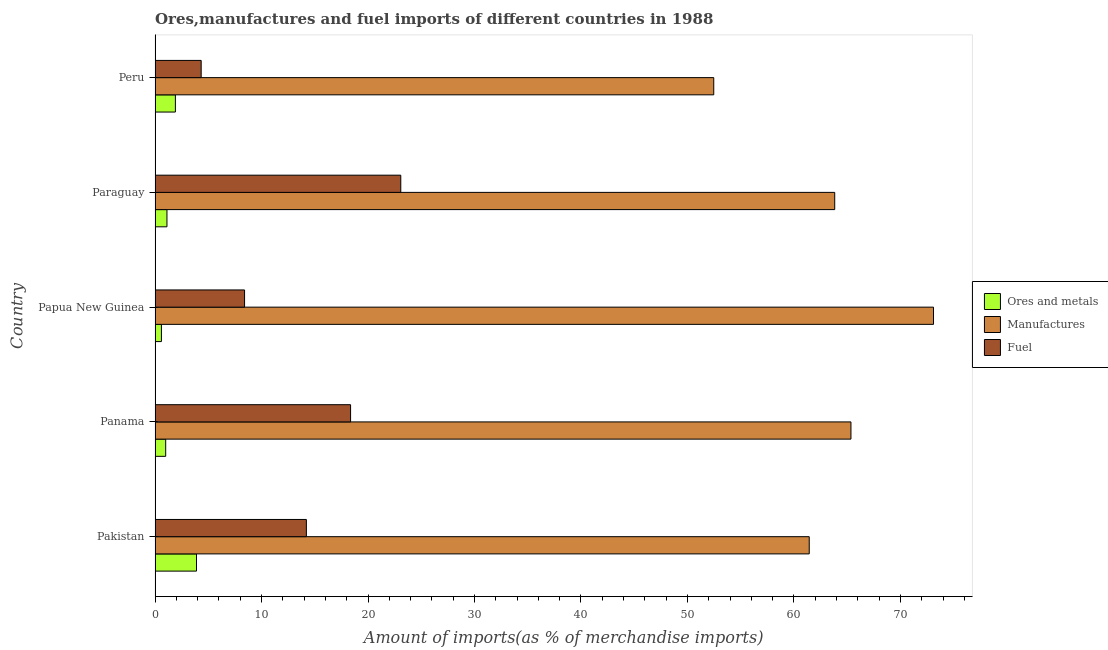How many groups of bars are there?
Offer a very short reply. 5. Are the number of bars per tick equal to the number of legend labels?
Ensure brevity in your answer.  Yes. Are the number of bars on each tick of the Y-axis equal?
Your response must be concise. Yes. In how many cases, is the number of bars for a given country not equal to the number of legend labels?
Offer a terse response. 0. What is the percentage of ores and metals imports in Pakistan?
Give a very brief answer. 3.89. Across all countries, what is the maximum percentage of manufactures imports?
Ensure brevity in your answer.  73.11. Across all countries, what is the minimum percentage of ores and metals imports?
Your answer should be compact. 0.6. In which country was the percentage of manufactures imports maximum?
Offer a terse response. Papua New Guinea. In which country was the percentage of ores and metals imports minimum?
Make the answer very short. Papua New Guinea. What is the total percentage of manufactures imports in the graph?
Provide a succinct answer. 316.19. What is the difference between the percentage of manufactures imports in Pakistan and that in Papua New Guinea?
Offer a terse response. -11.67. What is the difference between the percentage of ores and metals imports in Papua New Guinea and the percentage of manufactures imports in Peru?
Your answer should be very brief. -51.87. What is the average percentage of manufactures imports per country?
Provide a short and direct response. 63.24. What is the difference between the percentage of ores and metals imports and percentage of manufactures imports in Paraguay?
Make the answer very short. -62.71. What is the ratio of the percentage of manufactures imports in Pakistan to that in Papua New Guinea?
Keep it short and to the point. 0.84. Is the difference between the percentage of ores and metals imports in Panama and Papua New Guinea greater than the difference between the percentage of fuel imports in Panama and Papua New Guinea?
Keep it short and to the point. No. What is the difference between the highest and the second highest percentage of ores and metals imports?
Give a very brief answer. 1.98. What is the difference between the highest and the lowest percentage of ores and metals imports?
Your answer should be very brief. 3.29. In how many countries, is the percentage of manufactures imports greater than the average percentage of manufactures imports taken over all countries?
Provide a short and direct response. 3. What does the 3rd bar from the top in Panama represents?
Your response must be concise. Ores and metals. What does the 2nd bar from the bottom in Peru represents?
Your response must be concise. Manufactures. Is it the case that in every country, the sum of the percentage of ores and metals imports and percentage of manufactures imports is greater than the percentage of fuel imports?
Offer a terse response. Yes. How many bars are there?
Keep it short and to the point. 15. Are all the bars in the graph horizontal?
Keep it short and to the point. Yes. How many countries are there in the graph?
Make the answer very short. 5. What is the difference between two consecutive major ticks on the X-axis?
Ensure brevity in your answer.  10. Does the graph contain any zero values?
Your answer should be compact. No. Where does the legend appear in the graph?
Offer a terse response. Center right. How many legend labels are there?
Give a very brief answer. 3. How are the legend labels stacked?
Your response must be concise. Vertical. What is the title of the graph?
Provide a succinct answer. Ores,manufactures and fuel imports of different countries in 1988. What is the label or title of the X-axis?
Provide a succinct answer. Amount of imports(as % of merchandise imports). What is the label or title of the Y-axis?
Your response must be concise. Country. What is the Amount of imports(as % of merchandise imports) of Ores and metals in Pakistan?
Your response must be concise. 3.89. What is the Amount of imports(as % of merchandise imports) of Manufactures in Pakistan?
Give a very brief answer. 61.44. What is the Amount of imports(as % of merchandise imports) in Fuel in Pakistan?
Provide a succinct answer. 14.21. What is the Amount of imports(as % of merchandise imports) in Ores and metals in Panama?
Provide a succinct answer. 1. What is the Amount of imports(as % of merchandise imports) of Manufactures in Panama?
Provide a succinct answer. 65.35. What is the Amount of imports(as % of merchandise imports) in Fuel in Panama?
Ensure brevity in your answer.  18.36. What is the Amount of imports(as % of merchandise imports) in Ores and metals in Papua New Guinea?
Ensure brevity in your answer.  0.6. What is the Amount of imports(as % of merchandise imports) in Manufactures in Papua New Guinea?
Provide a short and direct response. 73.11. What is the Amount of imports(as % of merchandise imports) in Fuel in Papua New Guinea?
Your answer should be compact. 8.41. What is the Amount of imports(as % of merchandise imports) in Ores and metals in Paraguay?
Offer a terse response. 1.12. What is the Amount of imports(as % of merchandise imports) in Manufactures in Paraguay?
Provide a short and direct response. 63.83. What is the Amount of imports(as % of merchandise imports) in Fuel in Paraguay?
Provide a succinct answer. 23.08. What is the Amount of imports(as % of merchandise imports) of Ores and metals in Peru?
Keep it short and to the point. 1.91. What is the Amount of imports(as % of merchandise imports) in Manufactures in Peru?
Offer a very short reply. 52.47. What is the Amount of imports(as % of merchandise imports) in Fuel in Peru?
Keep it short and to the point. 4.33. Across all countries, what is the maximum Amount of imports(as % of merchandise imports) in Ores and metals?
Provide a short and direct response. 3.89. Across all countries, what is the maximum Amount of imports(as % of merchandise imports) of Manufactures?
Provide a succinct answer. 73.11. Across all countries, what is the maximum Amount of imports(as % of merchandise imports) in Fuel?
Keep it short and to the point. 23.08. Across all countries, what is the minimum Amount of imports(as % of merchandise imports) of Ores and metals?
Provide a succinct answer. 0.6. Across all countries, what is the minimum Amount of imports(as % of merchandise imports) in Manufactures?
Provide a short and direct response. 52.47. Across all countries, what is the minimum Amount of imports(as % of merchandise imports) of Fuel?
Keep it short and to the point. 4.33. What is the total Amount of imports(as % of merchandise imports) in Ores and metals in the graph?
Make the answer very short. 8.51. What is the total Amount of imports(as % of merchandise imports) in Manufactures in the graph?
Provide a succinct answer. 316.19. What is the total Amount of imports(as % of merchandise imports) in Fuel in the graph?
Provide a short and direct response. 68.39. What is the difference between the Amount of imports(as % of merchandise imports) of Ores and metals in Pakistan and that in Panama?
Provide a succinct answer. 2.89. What is the difference between the Amount of imports(as % of merchandise imports) in Manufactures in Pakistan and that in Panama?
Your answer should be very brief. -3.92. What is the difference between the Amount of imports(as % of merchandise imports) in Fuel in Pakistan and that in Panama?
Keep it short and to the point. -4.15. What is the difference between the Amount of imports(as % of merchandise imports) in Ores and metals in Pakistan and that in Papua New Guinea?
Your answer should be compact. 3.29. What is the difference between the Amount of imports(as % of merchandise imports) of Manufactures in Pakistan and that in Papua New Guinea?
Your response must be concise. -11.67. What is the difference between the Amount of imports(as % of merchandise imports) of Fuel in Pakistan and that in Papua New Guinea?
Give a very brief answer. 5.8. What is the difference between the Amount of imports(as % of merchandise imports) in Ores and metals in Pakistan and that in Paraguay?
Your answer should be very brief. 2.77. What is the difference between the Amount of imports(as % of merchandise imports) of Manufactures in Pakistan and that in Paraguay?
Ensure brevity in your answer.  -2.39. What is the difference between the Amount of imports(as % of merchandise imports) of Fuel in Pakistan and that in Paraguay?
Your answer should be very brief. -8.87. What is the difference between the Amount of imports(as % of merchandise imports) of Ores and metals in Pakistan and that in Peru?
Offer a very short reply. 1.98. What is the difference between the Amount of imports(as % of merchandise imports) of Manufactures in Pakistan and that in Peru?
Your answer should be very brief. 8.97. What is the difference between the Amount of imports(as % of merchandise imports) in Fuel in Pakistan and that in Peru?
Your response must be concise. 9.88. What is the difference between the Amount of imports(as % of merchandise imports) of Ores and metals in Panama and that in Papua New Guinea?
Keep it short and to the point. 0.4. What is the difference between the Amount of imports(as % of merchandise imports) of Manufactures in Panama and that in Papua New Guinea?
Keep it short and to the point. -7.75. What is the difference between the Amount of imports(as % of merchandise imports) in Fuel in Panama and that in Papua New Guinea?
Make the answer very short. 9.96. What is the difference between the Amount of imports(as % of merchandise imports) of Ores and metals in Panama and that in Paraguay?
Your answer should be compact. -0.12. What is the difference between the Amount of imports(as % of merchandise imports) in Manufactures in Panama and that in Paraguay?
Offer a very short reply. 1.52. What is the difference between the Amount of imports(as % of merchandise imports) of Fuel in Panama and that in Paraguay?
Keep it short and to the point. -4.72. What is the difference between the Amount of imports(as % of merchandise imports) in Ores and metals in Panama and that in Peru?
Offer a terse response. -0.91. What is the difference between the Amount of imports(as % of merchandise imports) of Manufactures in Panama and that in Peru?
Keep it short and to the point. 12.89. What is the difference between the Amount of imports(as % of merchandise imports) in Fuel in Panama and that in Peru?
Your response must be concise. 14.03. What is the difference between the Amount of imports(as % of merchandise imports) of Ores and metals in Papua New Guinea and that in Paraguay?
Your answer should be very brief. -0.52. What is the difference between the Amount of imports(as % of merchandise imports) in Manufactures in Papua New Guinea and that in Paraguay?
Make the answer very short. 9.28. What is the difference between the Amount of imports(as % of merchandise imports) of Fuel in Papua New Guinea and that in Paraguay?
Keep it short and to the point. -14.67. What is the difference between the Amount of imports(as % of merchandise imports) of Ores and metals in Papua New Guinea and that in Peru?
Give a very brief answer. -1.31. What is the difference between the Amount of imports(as % of merchandise imports) of Manufactures in Papua New Guinea and that in Peru?
Provide a short and direct response. 20.64. What is the difference between the Amount of imports(as % of merchandise imports) of Fuel in Papua New Guinea and that in Peru?
Keep it short and to the point. 4.07. What is the difference between the Amount of imports(as % of merchandise imports) of Ores and metals in Paraguay and that in Peru?
Your response must be concise. -0.79. What is the difference between the Amount of imports(as % of merchandise imports) in Manufactures in Paraguay and that in Peru?
Provide a succinct answer. 11.36. What is the difference between the Amount of imports(as % of merchandise imports) of Fuel in Paraguay and that in Peru?
Your answer should be compact. 18.75. What is the difference between the Amount of imports(as % of merchandise imports) of Ores and metals in Pakistan and the Amount of imports(as % of merchandise imports) of Manufactures in Panama?
Ensure brevity in your answer.  -61.46. What is the difference between the Amount of imports(as % of merchandise imports) of Ores and metals in Pakistan and the Amount of imports(as % of merchandise imports) of Fuel in Panama?
Keep it short and to the point. -14.47. What is the difference between the Amount of imports(as % of merchandise imports) of Manufactures in Pakistan and the Amount of imports(as % of merchandise imports) of Fuel in Panama?
Provide a short and direct response. 43.07. What is the difference between the Amount of imports(as % of merchandise imports) in Ores and metals in Pakistan and the Amount of imports(as % of merchandise imports) in Manufactures in Papua New Guinea?
Give a very brief answer. -69.22. What is the difference between the Amount of imports(as % of merchandise imports) in Ores and metals in Pakistan and the Amount of imports(as % of merchandise imports) in Fuel in Papua New Guinea?
Keep it short and to the point. -4.51. What is the difference between the Amount of imports(as % of merchandise imports) of Manufactures in Pakistan and the Amount of imports(as % of merchandise imports) of Fuel in Papua New Guinea?
Give a very brief answer. 53.03. What is the difference between the Amount of imports(as % of merchandise imports) of Ores and metals in Pakistan and the Amount of imports(as % of merchandise imports) of Manufactures in Paraguay?
Provide a short and direct response. -59.94. What is the difference between the Amount of imports(as % of merchandise imports) in Ores and metals in Pakistan and the Amount of imports(as % of merchandise imports) in Fuel in Paraguay?
Offer a very short reply. -19.19. What is the difference between the Amount of imports(as % of merchandise imports) of Manufactures in Pakistan and the Amount of imports(as % of merchandise imports) of Fuel in Paraguay?
Provide a short and direct response. 38.36. What is the difference between the Amount of imports(as % of merchandise imports) in Ores and metals in Pakistan and the Amount of imports(as % of merchandise imports) in Manufactures in Peru?
Provide a succinct answer. -48.58. What is the difference between the Amount of imports(as % of merchandise imports) of Ores and metals in Pakistan and the Amount of imports(as % of merchandise imports) of Fuel in Peru?
Your response must be concise. -0.44. What is the difference between the Amount of imports(as % of merchandise imports) in Manufactures in Pakistan and the Amount of imports(as % of merchandise imports) in Fuel in Peru?
Provide a short and direct response. 57.1. What is the difference between the Amount of imports(as % of merchandise imports) in Ores and metals in Panama and the Amount of imports(as % of merchandise imports) in Manufactures in Papua New Guinea?
Give a very brief answer. -72.11. What is the difference between the Amount of imports(as % of merchandise imports) in Ores and metals in Panama and the Amount of imports(as % of merchandise imports) in Fuel in Papua New Guinea?
Provide a succinct answer. -7.41. What is the difference between the Amount of imports(as % of merchandise imports) in Manufactures in Panama and the Amount of imports(as % of merchandise imports) in Fuel in Papua New Guinea?
Your answer should be very brief. 56.95. What is the difference between the Amount of imports(as % of merchandise imports) in Ores and metals in Panama and the Amount of imports(as % of merchandise imports) in Manufactures in Paraguay?
Your answer should be very brief. -62.83. What is the difference between the Amount of imports(as % of merchandise imports) of Ores and metals in Panama and the Amount of imports(as % of merchandise imports) of Fuel in Paraguay?
Your response must be concise. -22.08. What is the difference between the Amount of imports(as % of merchandise imports) of Manufactures in Panama and the Amount of imports(as % of merchandise imports) of Fuel in Paraguay?
Your response must be concise. 42.28. What is the difference between the Amount of imports(as % of merchandise imports) of Ores and metals in Panama and the Amount of imports(as % of merchandise imports) of Manufactures in Peru?
Make the answer very short. -51.47. What is the difference between the Amount of imports(as % of merchandise imports) of Ores and metals in Panama and the Amount of imports(as % of merchandise imports) of Fuel in Peru?
Your answer should be compact. -3.33. What is the difference between the Amount of imports(as % of merchandise imports) in Manufactures in Panama and the Amount of imports(as % of merchandise imports) in Fuel in Peru?
Offer a very short reply. 61.02. What is the difference between the Amount of imports(as % of merchandise imports) in Ores and metals in Papua New Guinea and the Amount of imports(as % of merchandise imports) in Manufactures in Paraguay?
Offer a terse response. -63.23. What is the difference between the Amount of imports(as % of merchandise imports) of Ores and metals in Papua New Guinea and the Amount of imports(as % of merchandise imports) of Fuel in Paraguay?
Your answer should be compact. -22.48. What is the difference between the Amount of imports(as % of merchandise imports) of Manufactures in Papua New Guinea and the Amount of imports(as % of merchandise imports) of Fuel in Paraguay?
Give a very brief answer. 50.03. What is the difference between the Amount of imports(as % of merchandise imports) of Ores and metals in Papua New Guinea and the Amount of imports(as % of merchandise imports) of Manufactures in Peru?
Make the answer very short. -51.87. What is the difference between the Amount of imports(as % of merchandise imports) of Ores and metals in Papua New Guinea and the Amount of imports(as % of merchandise imports) of Fuel in Peru?
Your answer should be very brief. -3.73. What is the difference between the Amount of imports(as % of merchandise imports) of Manufactures in Papua New Guinea and the Amount of imports(as % of merchandise imports) of Fuel in Peru?
Offer a very short reply. 68.78. What is the difference between the Amount of imports(as % of merchandise imports) of Ores and metals in Paraguay and the Amount of imports(as % of merchandise imports) of Manufactures in Peru?
Offer a very short reply. -51.35. What is the difference between the Amount of imports(as % of merchandise imports) in Ores and metals in Paraguay and the Amount of imports(as % of merchandise imports) in Fuel in Peru?
Make the answer very short. -3.21. What is the difference between the Amount of imports(as % of merchandise imports) in Manufactures in Paraguay and the Amount of imports(as % of merchandise imports) in Fuel in Peru?
Provide a succinct answer. 59.5. What is the average Amount of imports(as % of merchandise imports) in Ores and metals per country?
Keep it short and to the point. 1.7. What is the average Amount of imports(as % of merchandise imports) in Manufactures per country?
Keep it short and to the point. 63.24. What is the average Amount of imports(as % of merchandise imports) in Fuel per country?
Make the answer very short. 13.68. What is the difference between the Amount of imports(as % of merchandise imports) of Ores and metals and Amount of imports(as % of merchandise imports) of Manufactures in Pakistan?
Provide a short and direct response. -57.54. What is the difference between the Amount of imports(as % of merchandise imports) in Ores and metals and Amount of imports(as % of merchandise imports) in Fuel in Pakistan?
Keep it short and to the point. -10.32. What is the difference between the Amount of imports(as % of merchandise imports) of Manufactures and Amount of imports(as % of merchandise imports) of Fuel in Pakistan?
Your answer should be very brief. 47.22. What is the difference between the Amount of imports(as % of merchandise imports) of Ores and metals and Amount of imports(as % of merchandise imports) of Manufactures in Panama?
Your response must be concise. -64.36. What is the difference between the Amount of imports(as % of merchandise imports) of Ores and metals and Amount of imports(as % of merchandise imports) of Fuel in Panama?
Your answer should be compact. -17.36. What is the difference between the Amount of imports(as % of merchandise imports) of Manufactures and Amount of imports(as % of merchandise imports) of Fuel in Panama?
Your response must be concise. 46.99. What is the difference between the Amount of imports(as % of merchandise imports) of Ores and metals and Amount of imports(as % of merchandise imports) of Manufactures in Papua New Guinea?
Give a very brief answer. -72.51. What is the difference between the Amount of imports(as % of merchandise imports) of Ores and metals and Amount of imports(as % of merchandise imports) of Fuel in Papua New Guinea?
Give a very brief answer. -7.81. What is the difference between the Amount of imports(as % of merchandise imports) in Manufactures and Amount of imports(as % of merchandise imports) in Fuel in Papua New Guinea?
Make the answer very short. 64.7. What is the difference between the Amount of imports(as % of merchandise imports) in Ores and metals and Amount of imports(as % of merchandise imports) in Manufactures in Paraguay?
Offer a terse response. -62.71. What is the difference between the Amount of imports(as % of merchandise imports) in Ores and metals and Amount of imports(as % of merchandise imports) in Fuel in Paraguay?
Make the answer very short. -21.96. What is the difference between the Amount of imports(as % of merchandise imports) of Manufactures and Amount of imports(as % of merchandise imports) of Fuel in Paraguay?
Offer a very short reply. 40.75. What is the difference between the Amount of imports(as % of merchandise imports) in Ores and metals and Amount of imports(as % of merchandise imports) in Manufactures in Peru?
Your answer should be very brief. -50.56. What is the difference between the Amount of imports(as % of merchandise imports) in Ores and metals and Amount of imports(as % of merchandise imports) in Fuel in Peru?
Your answer should be compact. -2.42. What is the difference between the Amount of imports(as % of merchandise imports) in Manufactures and Amount of imports(as % of merchandise imports) in Fuel in Peru?
Offer a very short reply. 48.14. What is the ratio of the Amount of imports(as % of merchandise imports) of Ores and metals in Pakistan to that in Panama?
Offer a terse response. 3.9. What is the ratio of the Amount of imports(as % of merchandise imports) in Manufactures in Pakistan to that in Panama?
Give a very brief answer. 0.94. What is the ratio of the Amount of imports(as % of merchandise imports) of Fuel in Pakistan to that in Panama?
Keep it short and to the point. 0.77. What is the ratio of the Amount of imports(as % of merchandise imports) of Ores and metals in Pakistan to that in Papua New Guinea?
Give a very brief answer. 6.52. What is the ratio of the Amount of imports(as % of merchandise imports) of Manufactures in Pakistan to that in Papua New Guinea?
Offer a very short reply. 0.84. What is the ratio of the Amount of imports(as % of merchandise imports) in Fuel in Pakistan to that in Papua New Guinea?
Offer a very short reply. 1.69. What is the ratio of the Amount of imports(as % of merchandise imports) of Ores and metals in Pakistan to that in Paraguay?
Provide a short and direct response. 3.48. What is the ratio of the Amount of imports(as % of merchandise imports) of Manufactures in Pakistan to that in Paraguay?
Provide a short and direct response. 0.96. What is the ratio of the Amount of imports(as % of merchandise imports) of Fuel in Pakistan to that in Paraguay?
Offer a terse response. 0.62. What is the ratio of the Amount of imports(as % of merchandise imports) of Ores and metals in Pakistan to that in Peru?
Your answer should be compact. 2.04. What is the ratio of the Amount of imports(as % of merchandise imports) of Manufactures in Pakistan to that in Peru?
Give a very brief answer. 1.17. What is the ratio of the Amount of imports(as % of merchandise imports) in Fuel in Pakistan to that in Peru?
Your response must be concise. 3.28. What is the ratio of the Amount of imports(as % of merchandise imports) in Ores and metals in Panama to that in Papua New Guinea?
Your response must be concise. 1.67. What is the ratio of the Amount of imports(as % of merchandise imports) in Manufactures in Panama to that in Papua New Guinea?
Your answer should be compact. 0.89. What is the ratio of the Amount of imports(as % of merchandise imports) of Fuel in Panama to that in Papua New Guinea?
Offer a very short reply. 2.18. What is the ratio of the Amount of imports(as % of merchandise imports) of Ores and metals in Panama to that in Paraguay?
Offer a terse response. 0.89. What is the ratio of the Amount of imports(as % of merchandise imports) in Manufactures in Panama to that in Paraguay?
Keep it short and to the point. 1.02. What is the ratio of the Amount of imports(as % of merchandise imports) of Fuel in Panama to that in Paraguay?
Your response must be concise. 0.8. What is the ratio of the Amount of imports(as % of merchandise imports) of Ores and metals in Panama to that in Peru?
Your answer should be very brief. 0.52. What is the ratio of the Amount of imports(as % of merchandise imports) in Manufactures in Panama to that in Peru?
Offer a terse response. 1.25. What is the ratio of the Amount of imports(as % of merchandise imports) in Fuel in Panama to that in Peru?
Give a very brief answer. 4.24. What is the ratio of the Amount of imports(as % of merchandise imports) of Ores and metals in Papua New Guinea to that in Paraguay?
Your answer should be compact. 0.53. What is the ratio of the Amount of imports(as % of merchandise imports) in Manufactures in Papua New Guinea to that in Paraguay?
Offer a very short reply. 1.15. What is the ratio of the Amount of imports(as % of merchandise imports) in Fuel in Papua New Guinea to that in Paraguay?
Give a very brief answer. 0.36. What is the ratio of the Amount of imports(as % of merchandise imports) of Ores and metals in Papua New Guinea to that in Peru?
Give a very brief answer. 0.31. What is the ratio of the Amount of imports(as % of merchandise imports) in Manufactures in Papua New Guinea to that in Peru?
Your answer should be compact. 1.39. What is the ratio of the Amount of imports(as % of merchandise imports) in Fuel in Papua New Guinea to that in Peru?
Offer a very short reply. 1.94. What is the ratio of the Amount of imports(as % of merchandise imports) in Ores and metals in Paraguay to that in Peru?
Your answer should be very brief. 0.59. What is the ratio of the Amount of imports(as % of merchandise imports) in Manufactures in Paraguay to that in Peru?
Keep it short and to the point. 1.22. What is the ratio of the Amount of imports(as % of merchandise imports) in Fuel in Paraguay to that in Peru?
Make the answer very short. 5.33. What is the difference between the highest and the second highest Amount of imports(as % of merchandise imports) of Ores and metals?
Ensure brevity in your answer.  1.98. What is the difference between the highest and the second highest Amount of imports(as % of merchandise imports) in Manufactures?
Your answer should be compact. 7.75. What is the difference between the highest and the second highest Amount of imports(as % of merchandise imports) of Fuel?
Ensure brevity in your answer.  4.72. What is the difference between the highest and the lowest Amount of imports(as % of merchandise imports) of Ores and metals?
Ensure brevity in your answer.  3.29. What is the difference between the highest and the lowest Amount of imports(as % of merchandise imports) in Manufactures?
Offer a very short reply. 20.64. What is the difference between the highest and the lowest Amount of imports(as % of merchandise imports) of Fuel?
Provide a short and direct response. 18.75. 